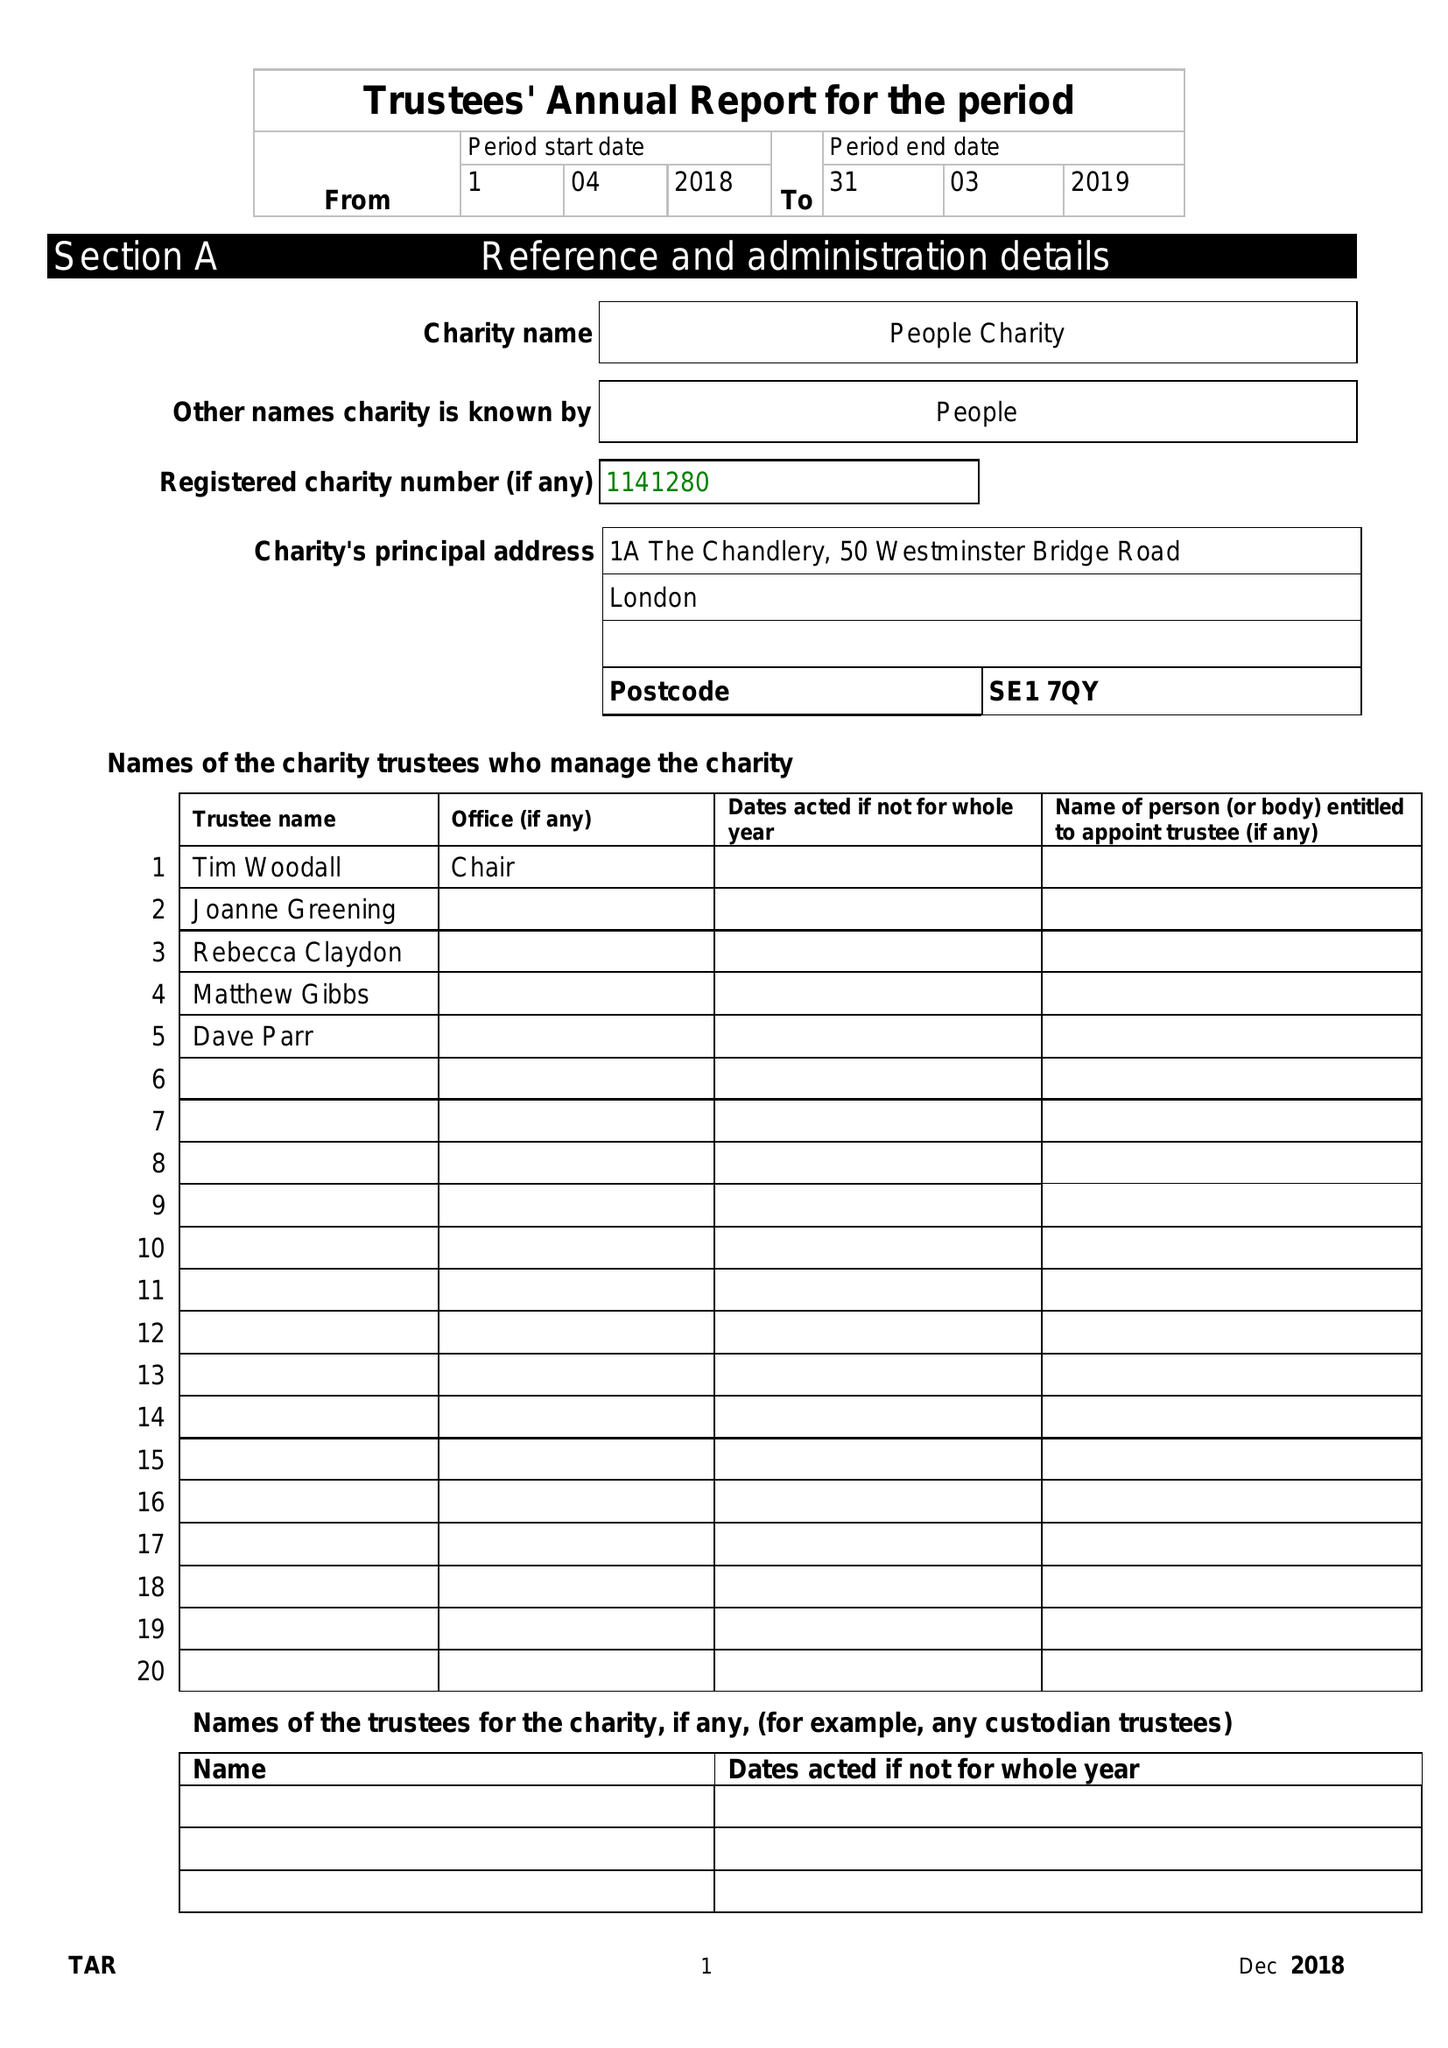What is the value for the address__street_line?
Answer the question using a single word or phrase. 50 WESTMINSTER BRIDGE ROAD 